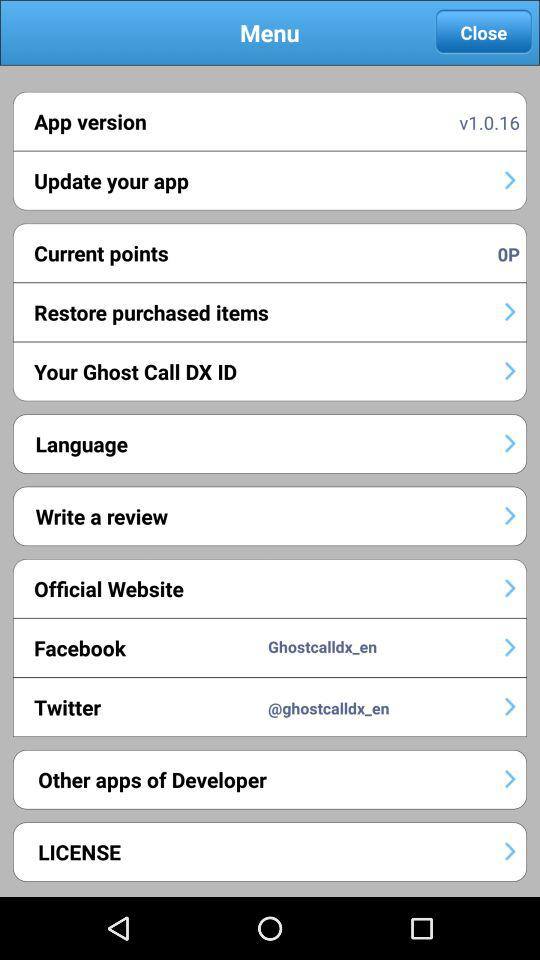When was the version updated?
When the provided information is insufficient, respond with <no answer>. <no answer> 